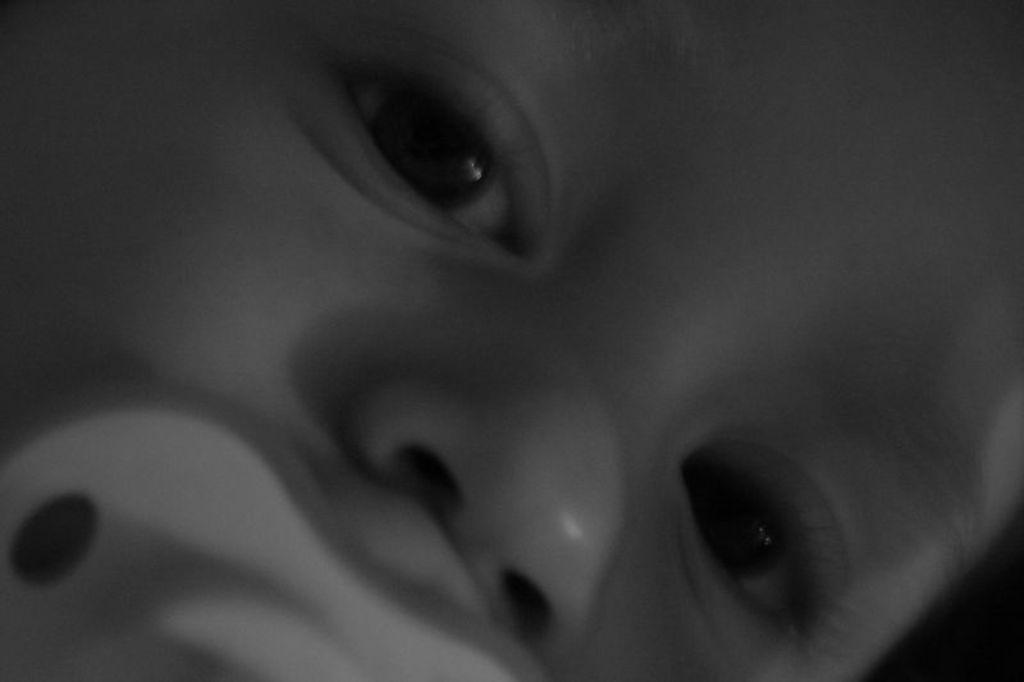What is the main subject of the image? The main subject of the image is a child's face. What is the child doing in the image? The child has a nipple in their mouth. Who is the creator of the dime in the image? There is no dime present in the image, so it is not possible to determine who created it. 